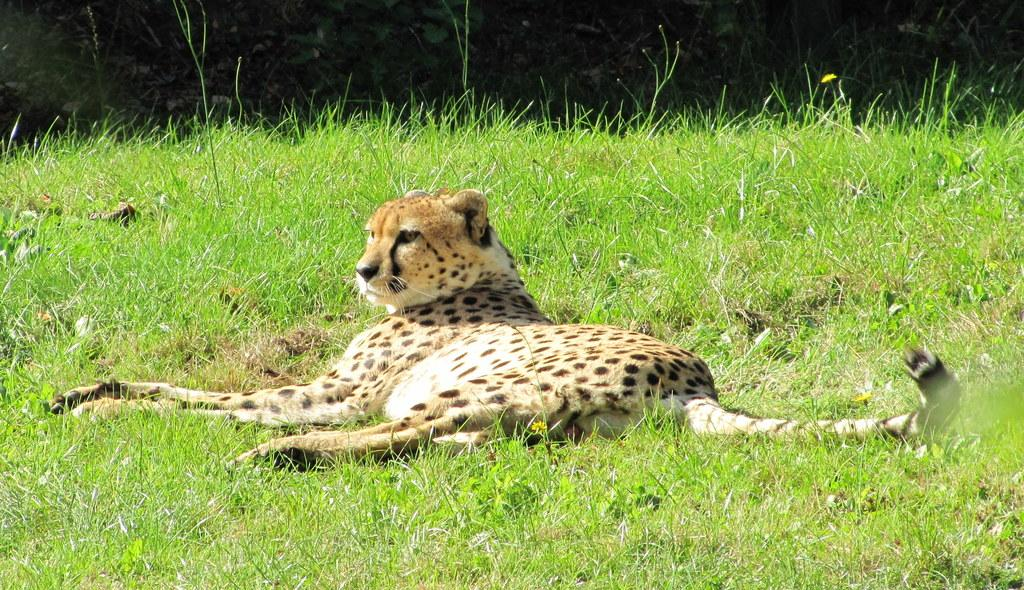What animal is the main subject of the picture? There is a tiger in the picture. What is the tiger doing in the image? The tiger is lying on the grass. Are there any other elements in the picture besides the tiger? There may be plants beside the tiger. What type of spoon can be seen in the tiger's paw in the image? There is no spoon present in the image; it features a tiger lying on the grass. How does the scene change when the tiger looks up at the sky? The image does not show the tiger looking up at the sky, so it's not possible to describe any changes in the scene. 